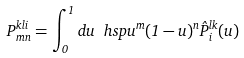Convert formula to latex. <formula><loc_0><loc_0><loc_500><loc_500>P ^ { k l i } _ { m n } = \int _ { 0 } ^ { 1 } d u \ h s p u ^ { m } ( 1 - u ) ^ { n } { \hat { P } } _ { i } ^ { l k } ( u )</formula> 